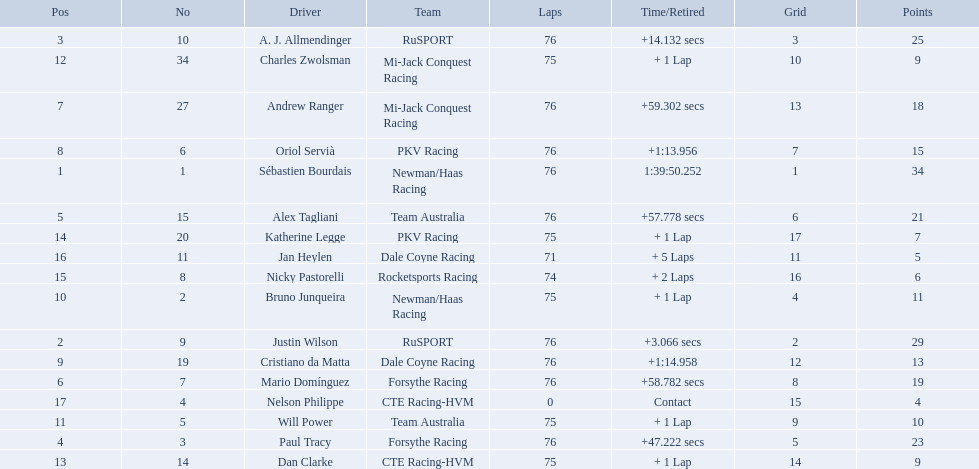Who drove during the 2006 tecate grand prix of monterrey? Sébastien Bourdais, Justin Wilson, A. J. Allmendinger, Paul Tracy, Alex Tagliani, Mario Domínguez, Andrew Ranger, Oriol Servià, Cristiano da Matta, Bruno Junqueira, Will Power, Charles Zwolsman, Dan Clarke, Katherine Legge, Nicky Pastorelli, Jan Heylen, Nelson Philippe. And what were their finishing positions? 1, 2, 3, 4, 5, 6, 7, 8, 9, 10, 11, 12, 13, 14, 15, 16, 17. Who did alex tagliani finish directly behind of? Paul Tracy. How many points did charles zwolsman acquire? 9. Who else got 9 points? Dan Clarke. 